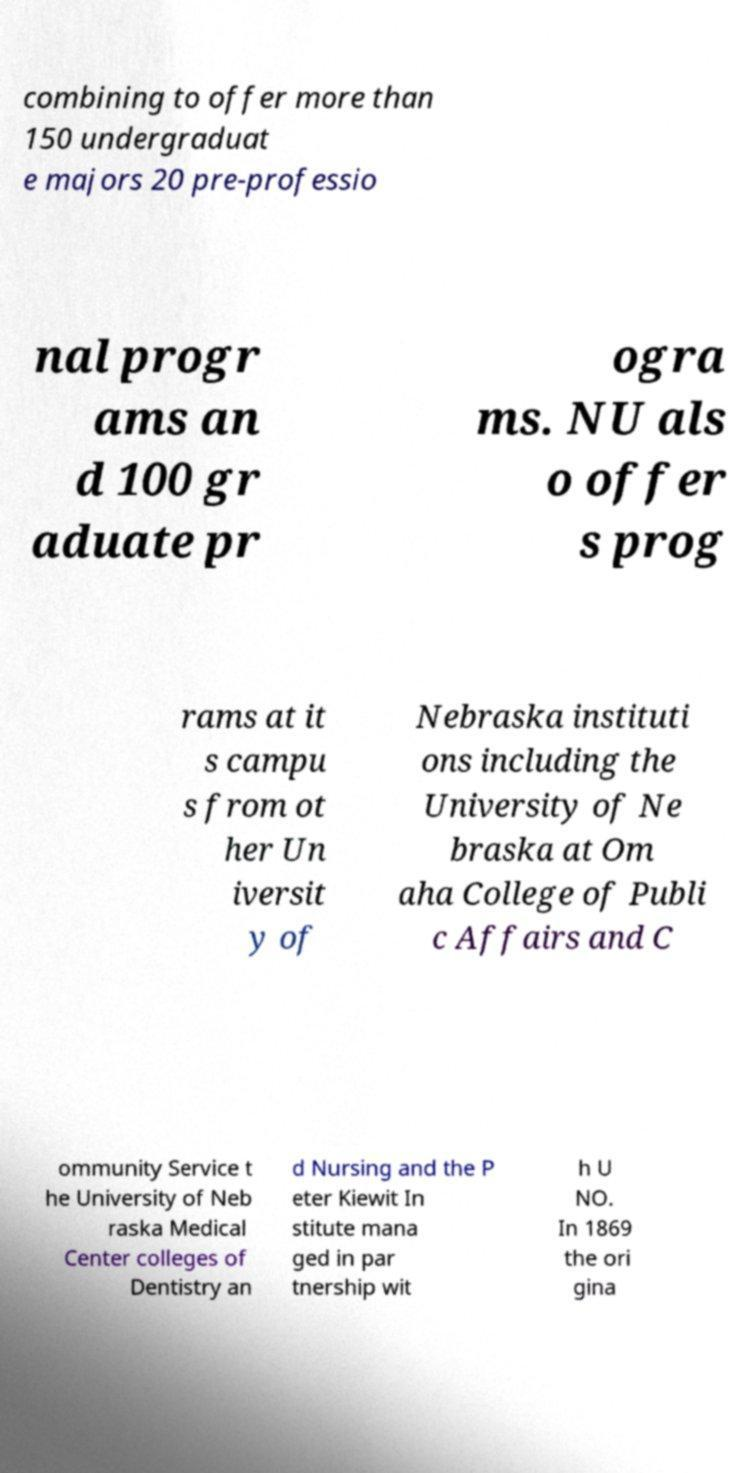Please identify and transcribe the text found in this image. combining to offer more than 150 undergraduat e majors 20 pre-professio nal progr ams an d 100 gr aduate pr ogra ms. NU als o offer s prog rams at it s campu s from ot her Un iversit y of Nebraska instituti ons including the University of Ne braska at Om aha College of Publi c Affairs and C ommunity Service t he University of Neb raska Medical Center colleges of Dentistry an d Nursing and the P eter Kiewit In stitute mana ged in par tnership wit h U NO. In 1869 the ori gina 